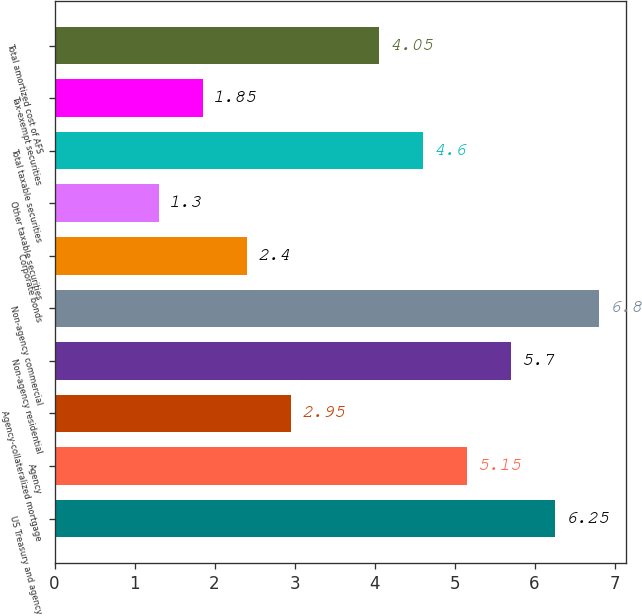Convert chart. <chart><loc_0><loc_0><loc_500><loc_500><bar_chart><fcel>US Treasury and agency<fcel>Agency<fcel>Agency-collateralized mortgage<fcel>Non-agency residential<fcel>Non-agency commercial<fcel>Corporate bonds<fcel>Other taxable securities<fcel>Total taxable securities<fcel>Tax-exempt securities<fcel>Total amortized cost of AFS<nl><fcel>6.25<fcel>5.15<fcel>2.95<fcel>5.7<fcel>6.8<fcel>2.4<fcel>1.3<fcel>4.6<fcel>1.85<fcel>4.05<nl></chart> 